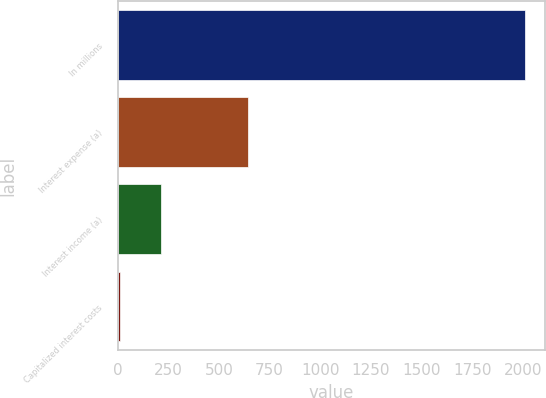Convert chart to OTSL. <chart><loc_0><loc_0><loc_500><loc_500><bar_chart><fcel>In millions<fcel>Interest expense (a)<fcel>Interest income (a)<fcel>Capitalized interest costs<nl><fcel>2010<fcel>643<fcel>213.6<fcel>14<nl></chart> 